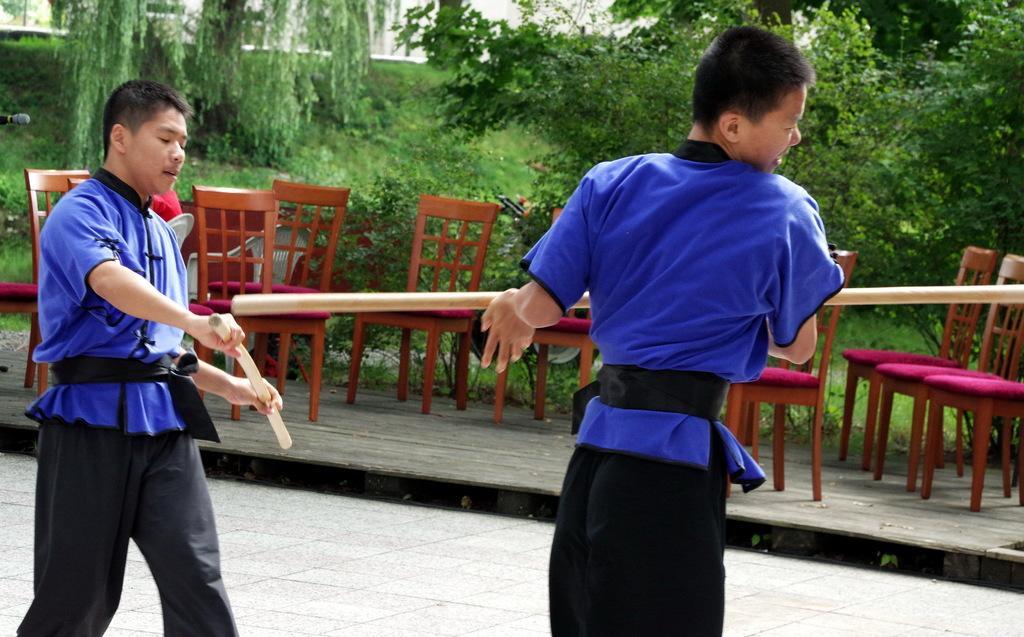How would you summarize this image in a sentence or two? In this picture I can observe two men wearing blue and black color dresses. They are holding sticks in their hands. I can observe brown color chairs. In the background there are trees and plants on the ground. 